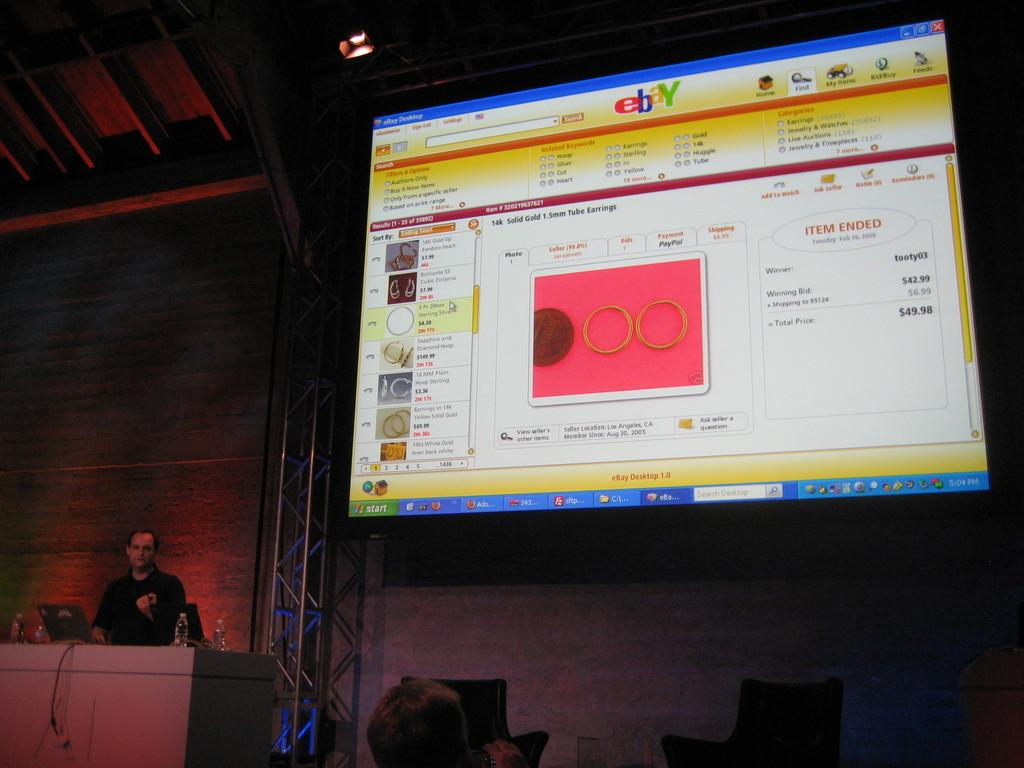<image>
Describe the image concisely. a computer with the site eBay being displayed 